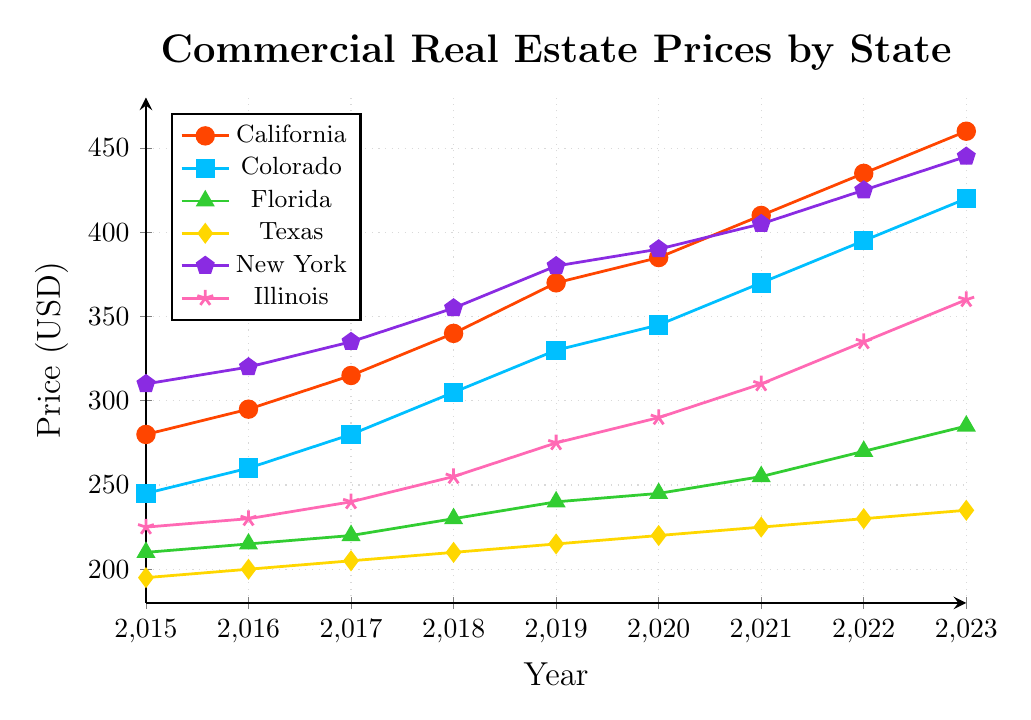What's the general trend for commercial real estate prices in California from 2015 to 2023? The prices in California show an overall increasing trend from 280 in 2015 to 460 in 2023, which indicates a consistent rise in commercial real estate prices over the years.
Answer: Increasing How do commercial real estate prices in 2023 compare between Colorado and Florida? In 2023, the commercial real estate price in Colorado is 420, while in Florida, it is 285. This shows that prices in Colorado are significantly higher than in Florida.
Answer: Higher in Colorado What was the average price of commercial real estate in New York over the period from 2015 to 2023? To find the average price, sum up the prices from 2015 to 2023, which are 310, 320, 335, 355, 380, 390, 405, 425, and 445. The total sum is 3365. Divide this by the number of years (9) to get the average price: 3365 / 9 ≈ 374.
Answer: 374 Which state had the lowest commercial real estate price in 2015, and what was the price? In 2015, Texas had the lowest commercial real estate price at 195 compared to other states.
Answer: Texas, 195 Which state showed the largest increase in commercial real estate prices between 2015 and 2023? Calculate the price increase for each state from 2015 to 2023: California (460-280=180), Colorado (420-245=175), Florida (285-210=75), Texas (235-195=40), New York (445-310=135), Illinois (360-225=135). California shows the largest increase.
Answer: California Compare the growth rates of commercial real estate prices in legalized cannabis states (California, Colorado, Illinois) between 2015 and 2023. For California, the increase is 180 (460-280). For Colorado, it is 175 (420-245). For Illinois, it is 135 (360-225). Therefore, California has the highest growth rate, followed by Colorado and then Illinois.
Answer: California > Colorado > Illinois In which year did New York surpass the $400 price mark for commercial real estate? By looking at the trend for New York, it surpassed the $400 mark in the year 2021 with a price of 405.
Answer: 2021 How did Florida’s commercial real estate prices change from 2020 to 2023? The price in Florida increased from 245 in 2020 to 285 in 2023. The change can be calculated as 285 - 245 = 40, indicating an increase of 40.
Answer: Increased by 40 Which state had a consistent year-over-year increase in commercial real estate prices without any decrease? By examining the trends, both California and Colorado show a consistent year-over-year increase without any decrease in prices from 2015 to 2023.
Answer: California and Colorado What was the price difference between Illinois and Texas in the year 2022? In 2022, Illinois had a price of 335 and Texas had a price of 230. The difference is 335 - 230 = 105.
Answer: 105 